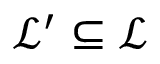Convert formula to latex. <formula><loc_0><loc_0><loc_500><loc_500>\mathcal { L } ^ { \prime } \subseteq \mathcal { L }</formula> 